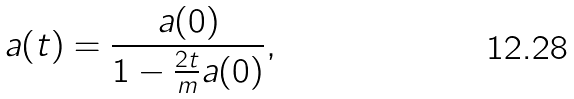Convert formula to latex. <formula><loc_0><loc_0><loc_500><loc_500>a ( t ) = \frac { a ( 0 ) } { 1 - \frac { 2 t } { m } a ( 0 ) } ,</formula> 